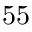Convert formula to latex. <formula><loc_0><loc_0><loc_500><loc_500>5 5</formula> 